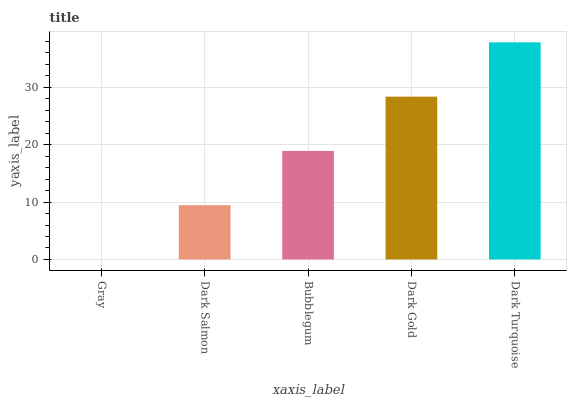Is Gray the minimum?
Answer yes or no. Yes. Is Dark Turquoise the maximum?
Answer yes or no. Yes. Is Dark Salmon the minimum?
Answer yes or no. No. Is Dark Salmon the maximum?
Answer yes or no. No. Is Dark Salmon greater than Gray?
Answer yes or no. Yes. Is Gray less than Dark Salmon?
Answer yes or no. Yes. Is Gray greater than Dark Salmon?
Answer yes or no. No. Is Dark Salmon less than Gray?
Answer yes or no. No. Is Bubblegum the high median?
Answer yes or no. Yes. Is Bubblegum the low median?
Answer yes or no. Yes. Is Dark Salmon the high median?
Answer yes or no. No. Is Gray the low median?
Answer yes or no. No. 